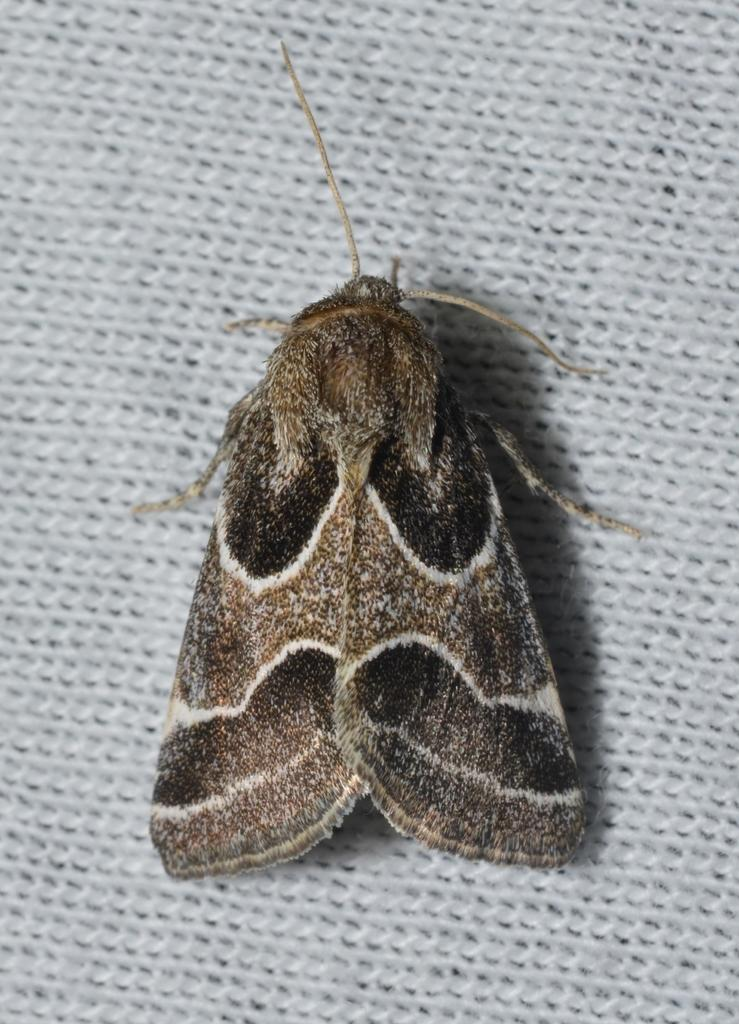What type of living organism can be seen in the image? There is an insect in the image. What is the color of the background in the image? The background of the image is white. What type of pan is being used by the daughter in the image? There is no daughter or pan present in the image. 